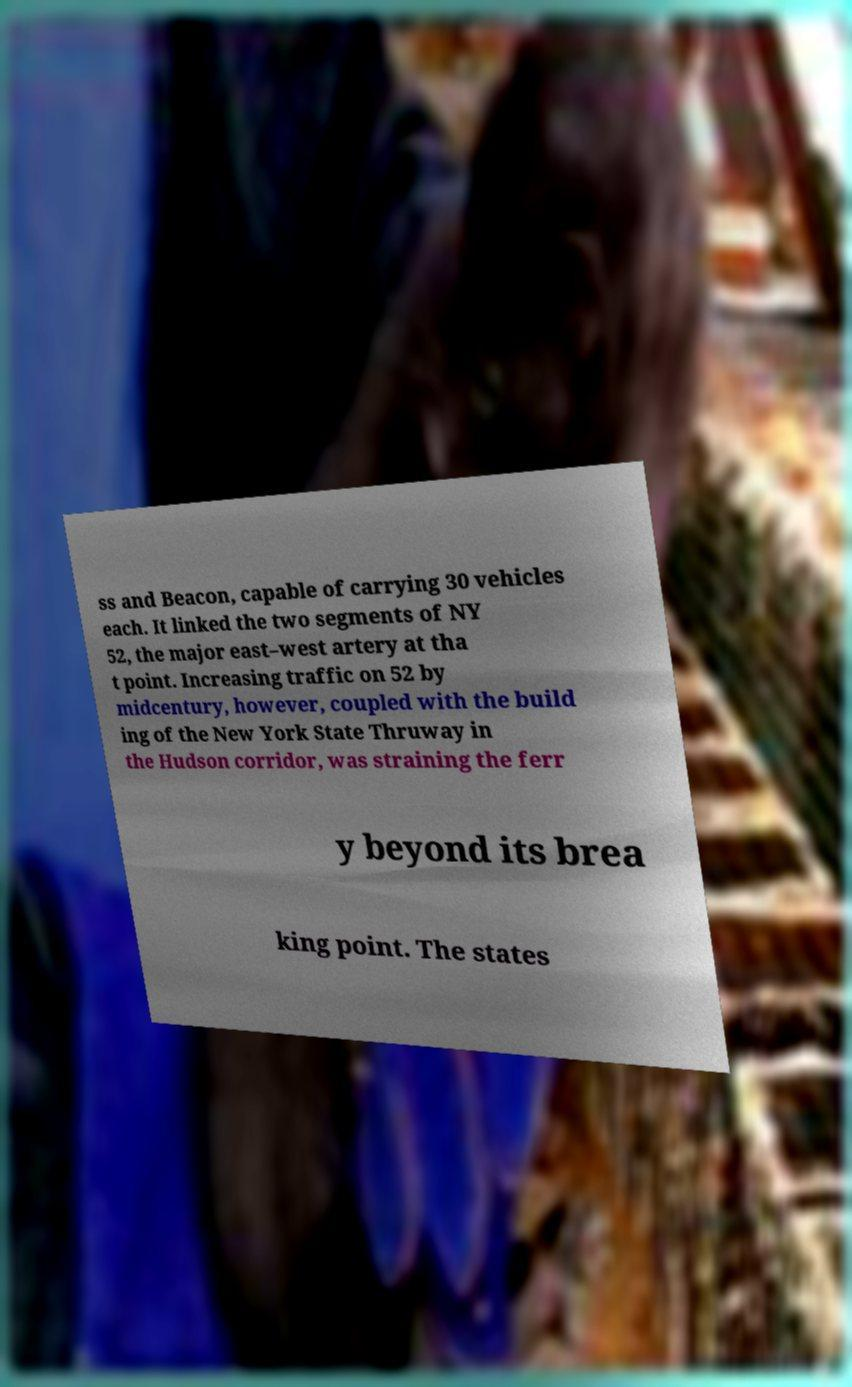Can you accurately transcribe the text from the provided image for me? ss and Beacon, capable of carrying 30 vehicles each. It linked the two segments of NY 52, the major east–west artery at tha t point. Increasing traffic on 52 by midcentury, however, coupled with the build ing of the New York State Thruway in the Hudson corridor, was straining the ferr y beyond its brea king point. The states 